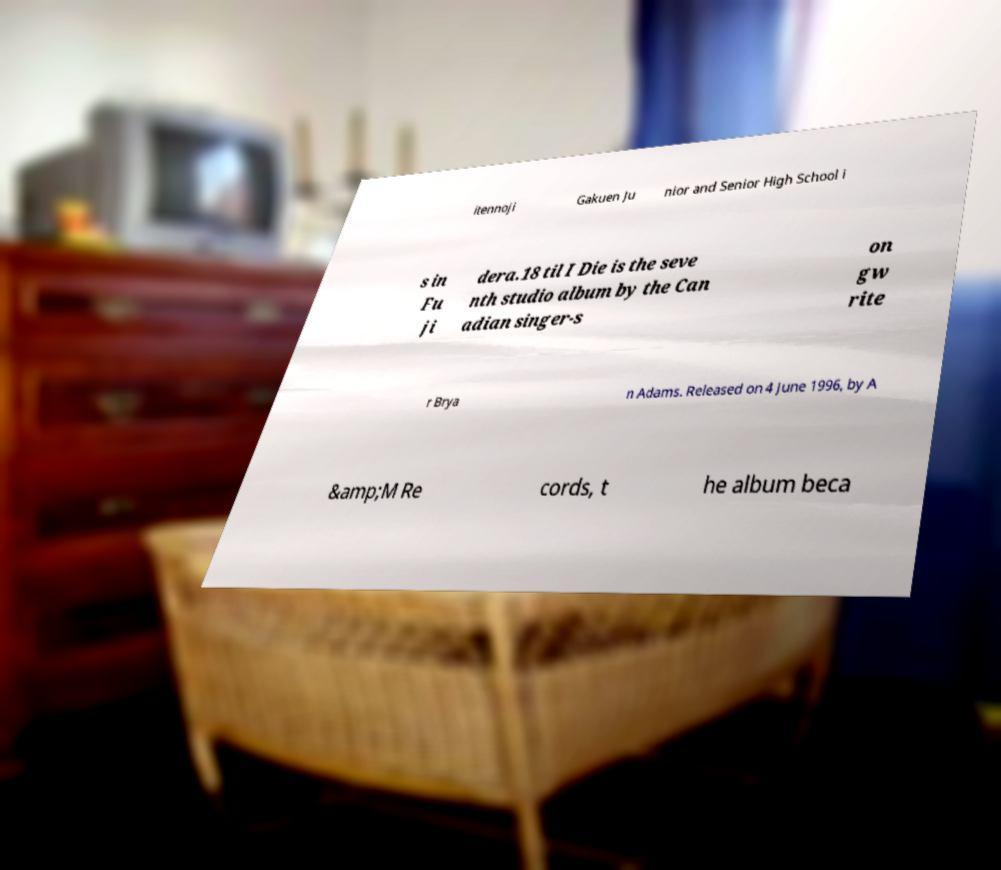Can you read and provide the text displayed in the image?This photo seems to have some interesting text. Can you extract and type it out for me? itennoji Gakuen Ju nior and Senior High School i s in Fu ji dera.18 til I Die is the seve nth studio album by the Can adian singer-s on gw rite r Brya n Adams. Released on 4 June 1996, by A &amp;M Re cords, t he album beca 